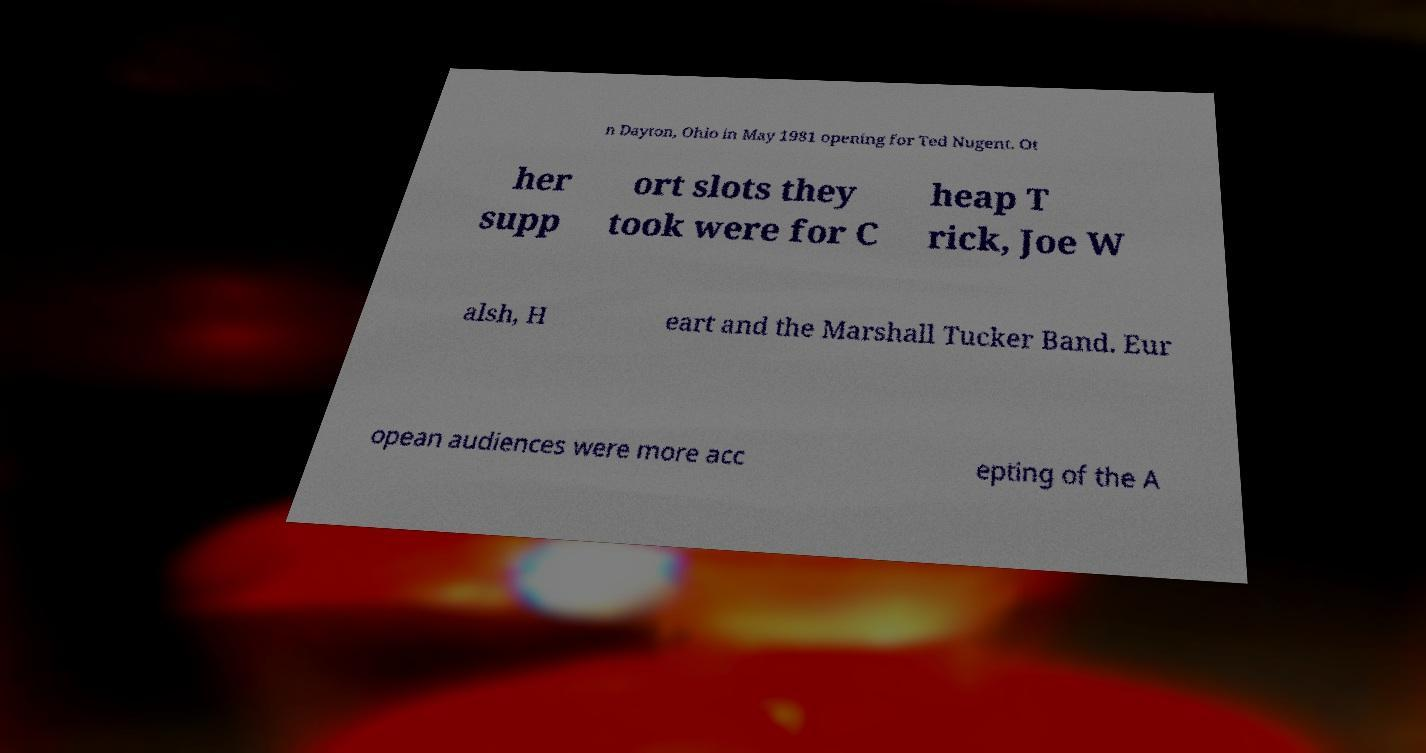I need the written content from this picture converted into text. Can you do that? n Dayton, Ohio in May 1981 opening for Ted Nugent. Ot her supp ort slots they took were for C heap T rick, Joe W alsh, H eart and the Marshall Tucker Band. Eur opean audiences were more acc epting of the A 